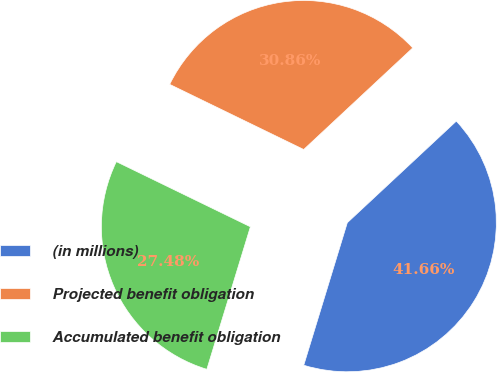Convert chart. <chart><loc_0><loc_0><loc_500><loc_500><pie_chart><fcel>(in millions)<fcel>Projected benefit obligation<fcel>Accumulated benefit obligation<nl><fcel>41.66%<fcel>30.86%<fcel>27.48%<nl></chart> 